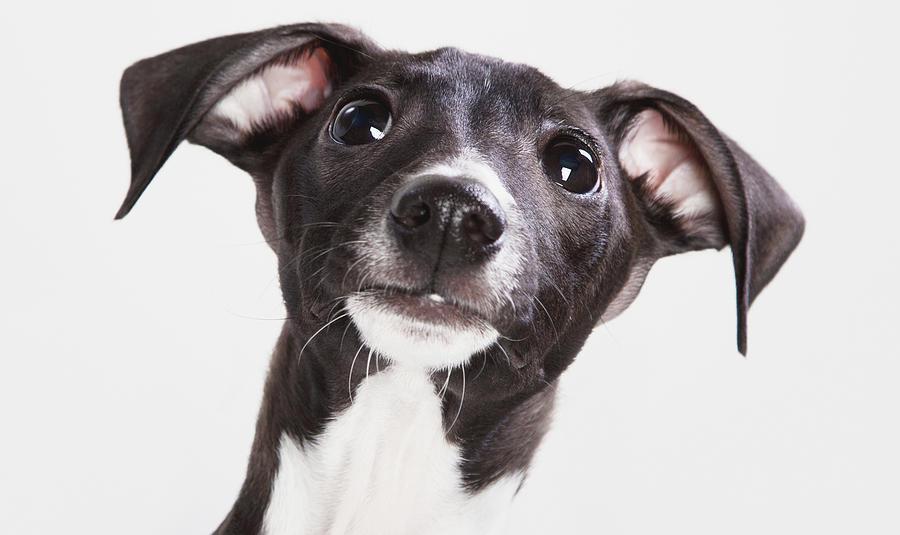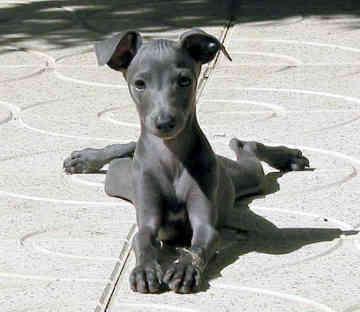The first image is the image on the left, the second image is the image on the right. Examine the images to the left and right. Is the description "The dog in one of the images is on a cemented area outside." accurate? Answer yes or no. Yes. The first image is the image on the left, the second image is the image on the right. For the images shown, is this caption "An image shows a dog wearing a garment with a turtleneck." true? Answer yes or no. No. 